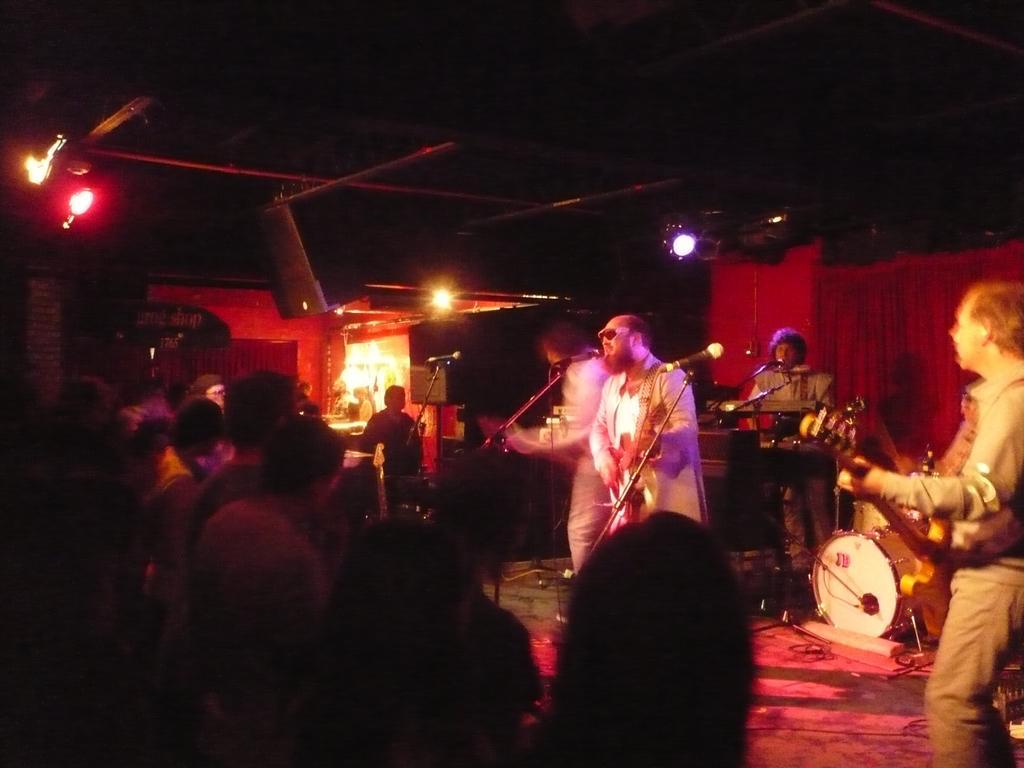How would you summarize this image in a sentence or two? In this image I see 4 men on the stage and all of them are with the musical instruments and they are in front of the mics, I can also see few people over here and lights. 